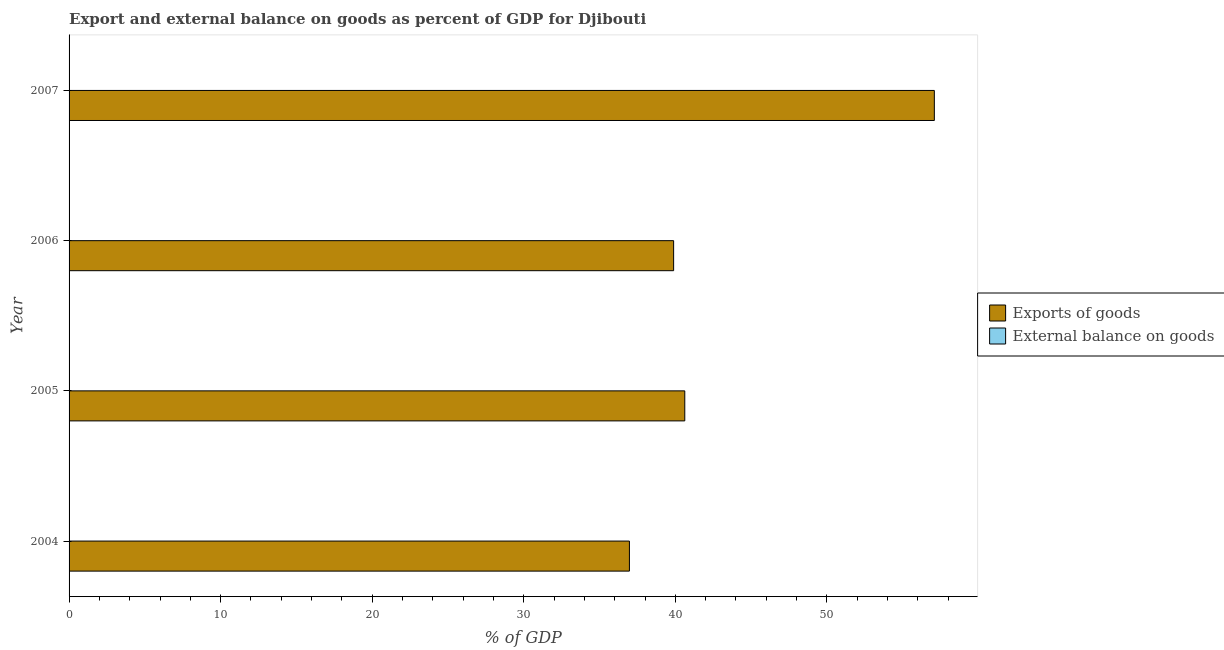How many different coloured bars are there?
Provide a short and direct response. 1. Are the number of bars per tick equal to the number of legend labels?
Make the answer very short. No. Are the number of bars on each tick of the Y-axis equal?
Your response must be concise. Yes. What is the label of the 1st group of bars from the top?
Your answer should be very brief. 2007. In how many cases, is the number of bars for a given year not equal to the number of legend labels?
Ensure brevity in your answer.  4. Across all years, what is the maximum export of goods as percentage of gdp?
Give a very brief answer. 57.09. Across all years, what is the minimum external balance on goods as percentage of gdp?
Give a very brief answer. 0. In which year was the export of goods as percentage of gdp maximum?
Keep it short and to the point. 2007. What is the total external balance on goods as percentage of gdp in the graph?
Provide a short and direct response. 0. What is the difference between the export of goods as percentage of gdp in 2006 and that in 2007?
Your answer should be very brief. -17.2. What is the difference between the export of goods as percentage of gdp in 2006 and the external balance on goods as percentage of gdp in 2007?
Your answer should be very brief. 39.89. What is the average export of goods as percentage of gdp per year?
Provide a short and direct response. 43.64. What is the ratio of the export of goods as percentage of gdp in 2006 to that in 2007?
Offer a very short reply. 0.7. Is the export of goods as percentage of gdp in 2004 less than that in 2006?
Ensure brevity in your answer.  Yes. What is the difference between the highest and the second highest export of goods as percentage of gdp?
Offer a very short reply. 16.46. What is the difference between the highest and the lowest export of goods as percentage of gdp?
Your answer should be very brief. 20.12. In how many years, is the external balance on goods as percentage of gdp greater than the average external balance on goods as percentage of gdp taken over all years?
Make the answer very short. 0. Is the sum of the export of goods as percentage of gdp in 2004 and 2006 greater than the maximum external balance on goods as percentage of gdp across all years?
Keep it short and to the point. Yes. What is the difference between two consecutive major ticks on the X-axis?
Provide a succinct answer. 10. Are the values on the major ticks of X-axis written in scientific E-notation?
Provide a short and direct response. No. Does the graph contain any zero values?
Provide a short and direct response. Yes. How many legend labels are there?
Provide a short and direct response. 2. How are the legend labels stacked?
Your answer should be compact. Vertical. What is the title of the graph?
Offer a very short reply. Export and external balance on goods as percent of GDP for Djibouti. Does "Drinking water services" appear as one of the legend labels in the graph?
Offer a very short reply. No. What is the label or title of the X-axis?
Offer a very short reply. % of GDP. What is the % of GDP of Exports of goods in 2004?
Make the answer very short. 36.97. What is the % of GDP of External balance on goods in 2004?
Your response must be concise. 0. What is the % of GDP in Exports of goods in 2005?
Offer a terse response. 40.62. What is the % of GDP of External balance on goods in 2005?
Ensure brevity in your answer.  0. What is the % of GDP in Exports of goods in 2006?
Make the answer very short. 39.89. What is the % of GDP in Exports of goods in 2007?
Offer a very short reply. 57.09. Across all years, what is the maximum % of GDP in Exports of goods?
Your response must be concise. 57.09. Across all years, what is the minimum % of GDP in Exports of goods?
Make the answer very short. 36.97. What is the total % of GDP in Exports of goods in the graph?
Make the answer very short. 174.57. What is the difference between the % of GDP in Exports of goods in 2004 and that in 2005?
Give a very brief answer. -3.65. What is the difference between the % of GDP in Exports of goods in 2004 and that in 2006?
Ensure brevity in your answer.  -2.92. What is the difference between the % of GDP of Exports of goods in 2004 and that in 2007?
Your answer should be very brief. -20.12. What is the difference between the % of GDP in Exports of goods in 2005 and that in 2006?
Your answer should be very brief. 0.74. What is the difference between the % of GDP of Exports of goods in 2005 and that in 2007?
Your response must be concise. -16.47. What is the difference between the % of GDP of Exports of goods in 2006 and that in 2007?
Keep it short and to the point. -17.2. What is the average % of GDP of Exports of goods per year?
Your response must be concise. 43.64. What is the average % of GDP in External balance on goods per year?
Offer a terse response. 0. What is the ratio of the % of GDP in Exports of goods in 2004 to that in 2005?
Provide a succinct answer. 0.91. What is the ratio of the % of GDP of Exports of goods in 2004 to that in 2006?
Give a very brief answer. 0.93. What is the ratio of the % of GDP of Exports of goods in 2004 to that in 2007?
Give a very brief answer. 0.65. What is the ratio of the % of GDP in Exports of goods in 2005 to that in 2006?
Make the answer very short. 1.02. What is the ratio of the % of GDP in Exports of goods in 2005 to that in 2007?
Your response must be concise. 0.71. What is the ratio of the % of GDP in Exports of goods in 2006 to that in 2007?
Ensure brevity in your answer.  0.7. What is the difference between the highest and the second highest % of GDP of Exports of goods?
Your answer should be compact. 16.47. What is the difference between the highest and the lowest % of GDP of Exports of goods?
Offer a very short reply. 20.12. 